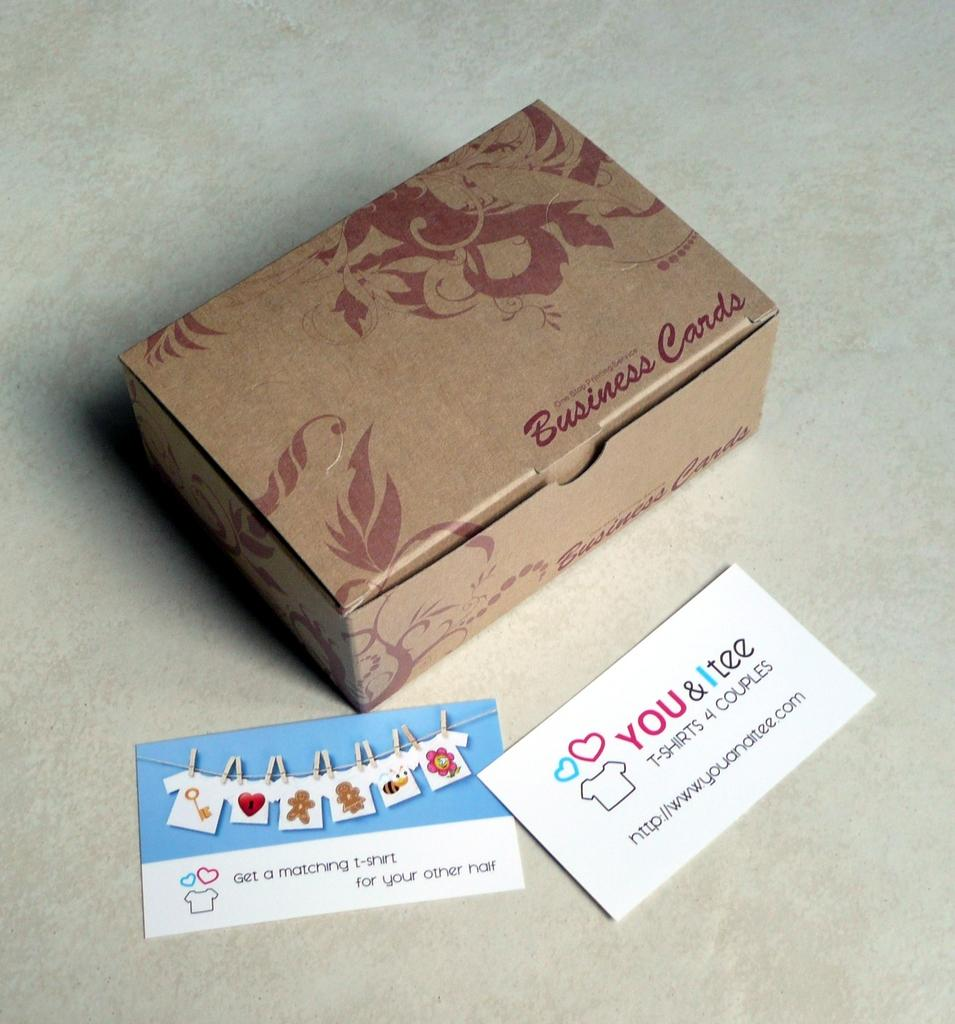<image>
Offer a succinct explanation of the picture presented. A business card for You and I tee sits near a box of cards. 